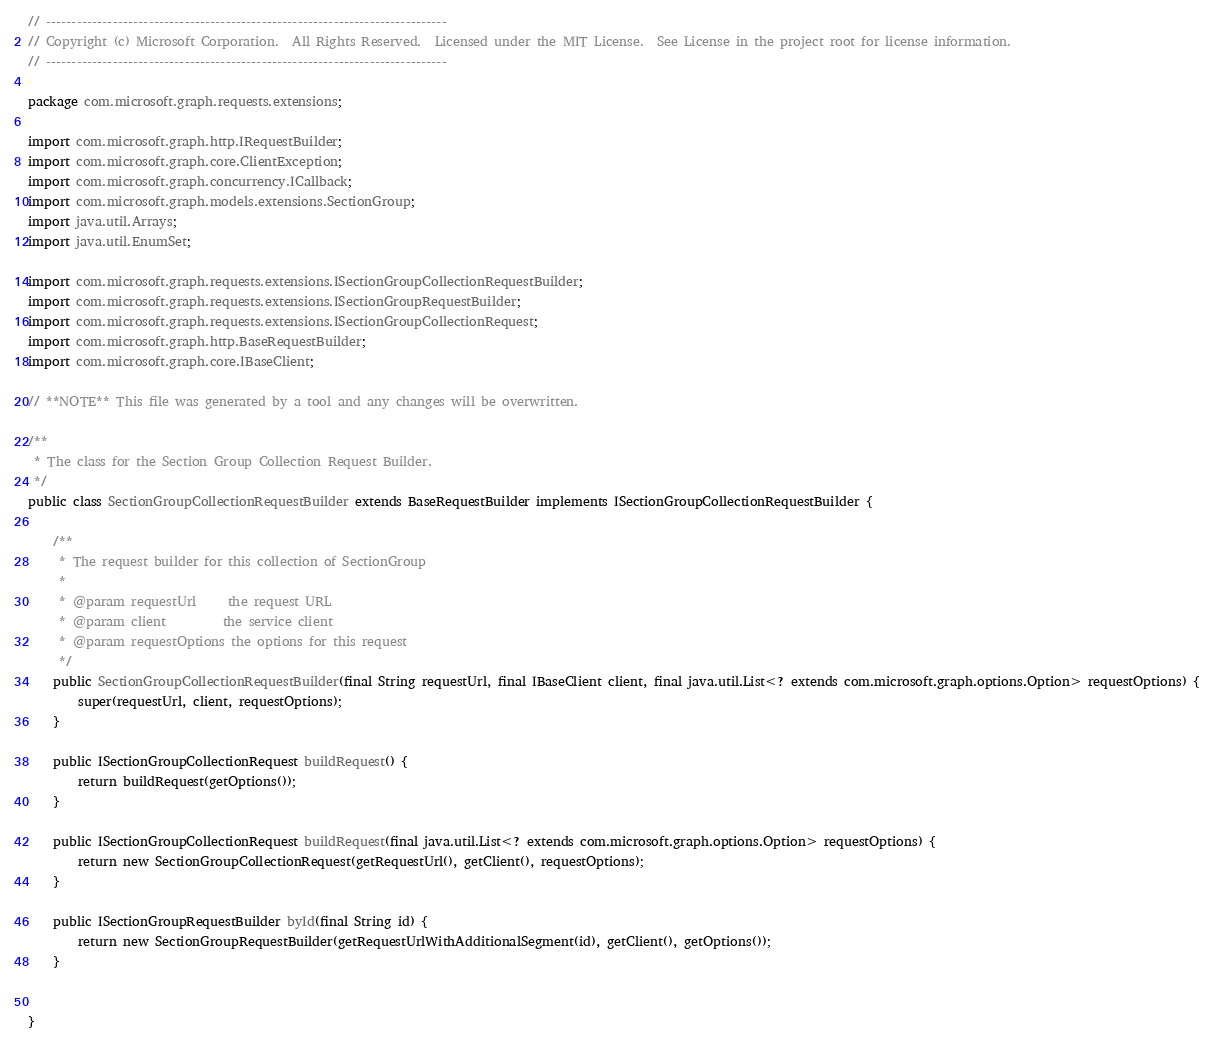Convert code to text. <code><loc_0><loc_0><loc_500><loc_500><_Java_>// ------------------------------------------------------------------------------
// Copyright (c) Microsoft Corporation.  All Rights Reserved.  Licensed under the MIT License.  See License in the project root for license information.
// ------------------------------------------------------------------------------

package com.microsoft.graph.requests.extensions;

import com.microsoft.graph.http.IRequestBuilder;
import com.microsoft.graph.core.ClientException;
import com.microsoft.graph.concurrency.ICallback;
import com.microsoft.graph.models.extensions.SectionGroup;
import java.util.Arrays;
import java.util.EnumSet;

import com.microsoft.graph.requests.extensions.ISectionGroupCollectionRequestBuilder;
import com.microsoft.graph.requests.extensions.ISectionGroupRequestBuilder;
import com.microsoft.graph.requests.extensions.ISectionGroupCollectionRequest;
import com.microsoft.graph.http.BaseRequestBuilder;
import com.microsoft.graph.core.IBaseClient;

// **NOTE** This file was generated by a tool and any changes will be overwritten.

/**
 * The class for the Section Group Collection Request Builder.
 */
public class SectionGroupCollectionRequestBuilder extends BaseRequestBuilder implements ISectionGroupCollectionRequestBuilder {

    /**
     * The request builder for this collection of SectionGroup
     *
     * @param requestUrl     the request URL
     * @param client         the service client
     * @param requestOptions the options for this request
     */
    public SectionGroupCollectionRequestBuilder(final String requestUrl, final IBaseClient client, final java.util.List<? extends com.microsoft.graph.options.Option> requestOptions) {
        super(requestUrl, client, requestOptions);
    }

    public ISectionGroupCollectionRequest buildRequest() {
        return buildRequest(getOptions());
    }

    public ISectionGroupCollectionRequest buildRequest(final java.util.List<? extends com.microsoft.graph.options.Option> requestOptions) {
        return new SectionGroupCollectionRequest(getRequestUrl(), getClient(), requestOptions);
    }

    public ISectionGroupRequestBuilder byId(final String id) {
        return new SectionGroupRequestBuilder(getRequestUrlWithAdditionalSegment(id), getClient(), getOptions());
    }


}
</code> 